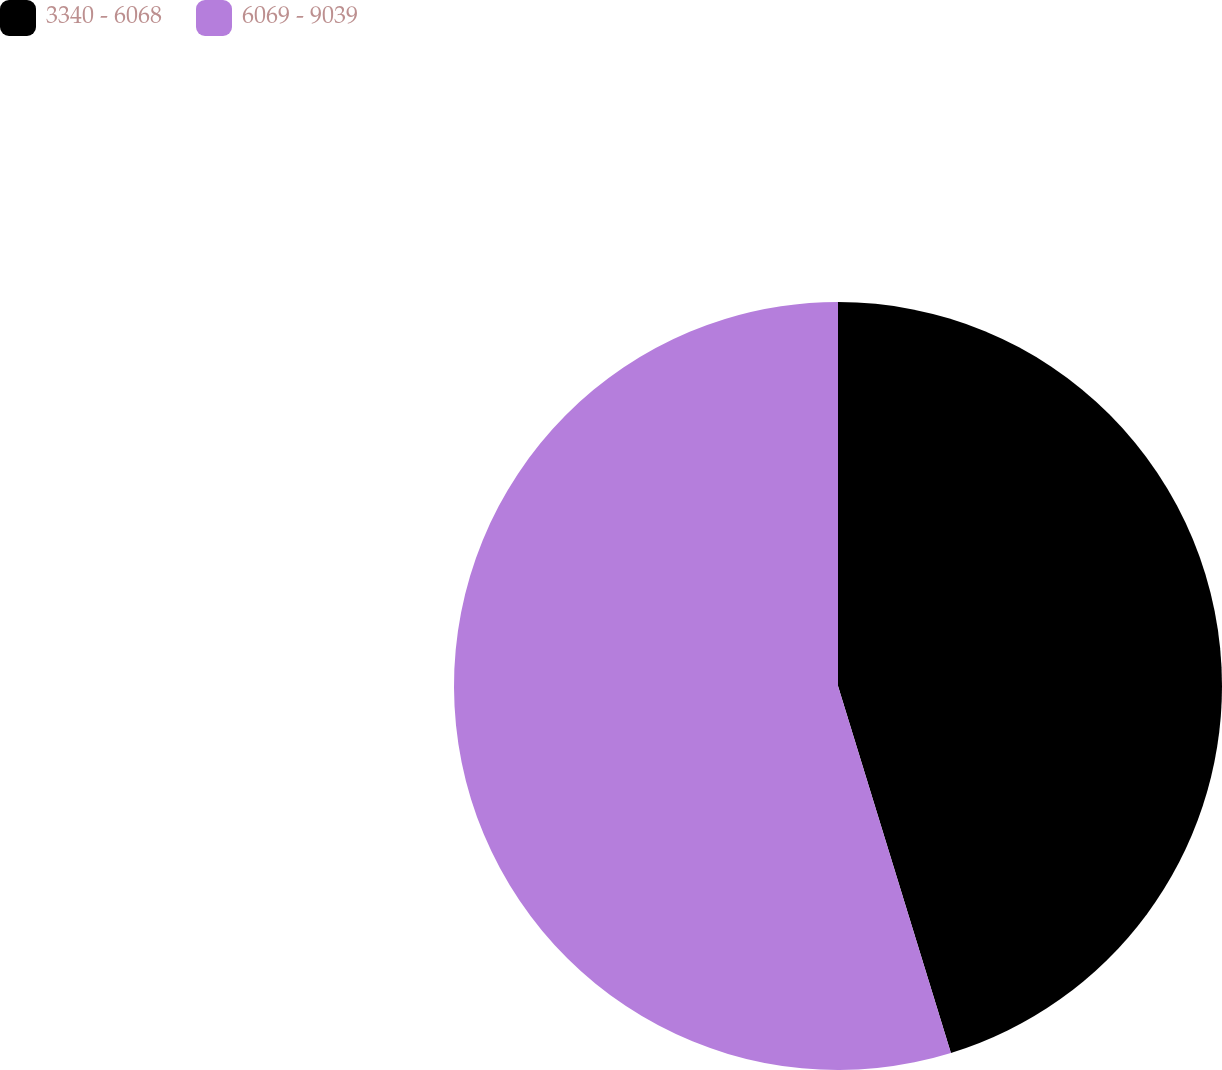Convert chart to OTSL. <chart><loc_0><loc_0><loc_500><loc_500><pie_chart><fcel>3340 - 6068<fcel>6069 - 9039<nl><fcel>45.25%<fcel>54.75%<nl></chart> 